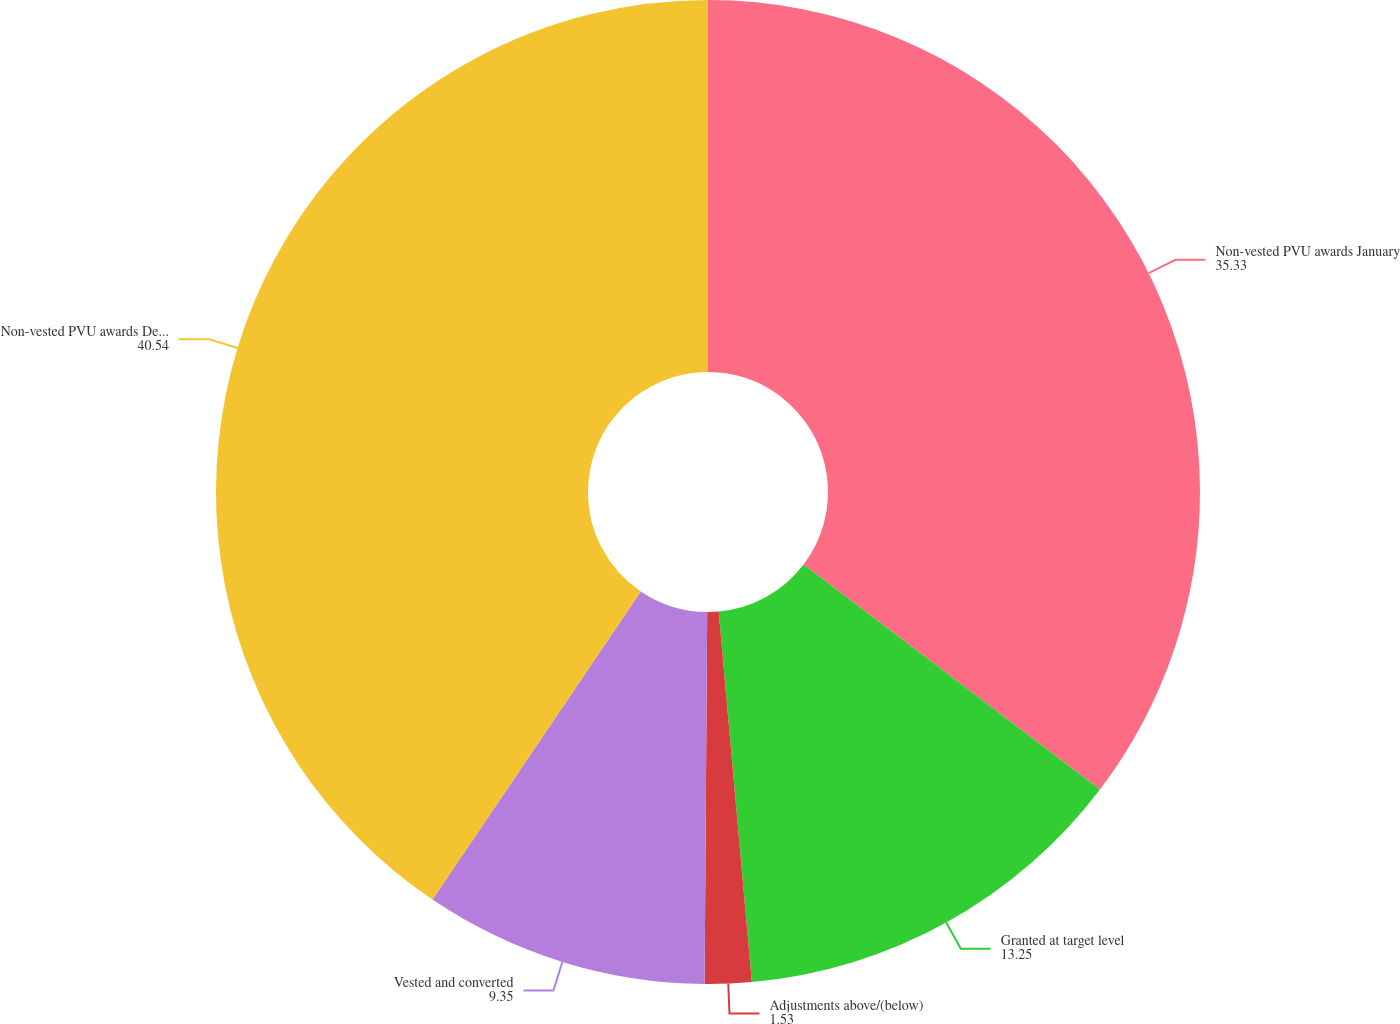<chart> <loc_0><loc_0><loc_500><loc_500><pie_chart><fcel>Non-vested PVU awards January<fcel>Granted at target level<fcel>Adjustments above/(below)<fcel>Vested and converted<fcel>Non-vested PVU awards December<nl><fcel>35.33%<fcel>13.25%<fcel>1.53%<fcel>9.35%<fcel>40.54%<nl></chart> 